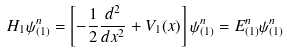<formula> <loc_0><loc_0><loc_500><loc_500>H _ { 1 } \psi ^ { n } _ { ( 1 ) } = \left [ - \frac { 1 } { 2 } \frac { d ^ { 2 } } { d x ^ { 2 } } + V _ { 1 } ( x ) \right ] \psi ^ { n } _ { ( 1 ) } = E ^ { n } _ { ( 1 ) } \psi ^ { n } _ { ( 1 ) }</formula> 